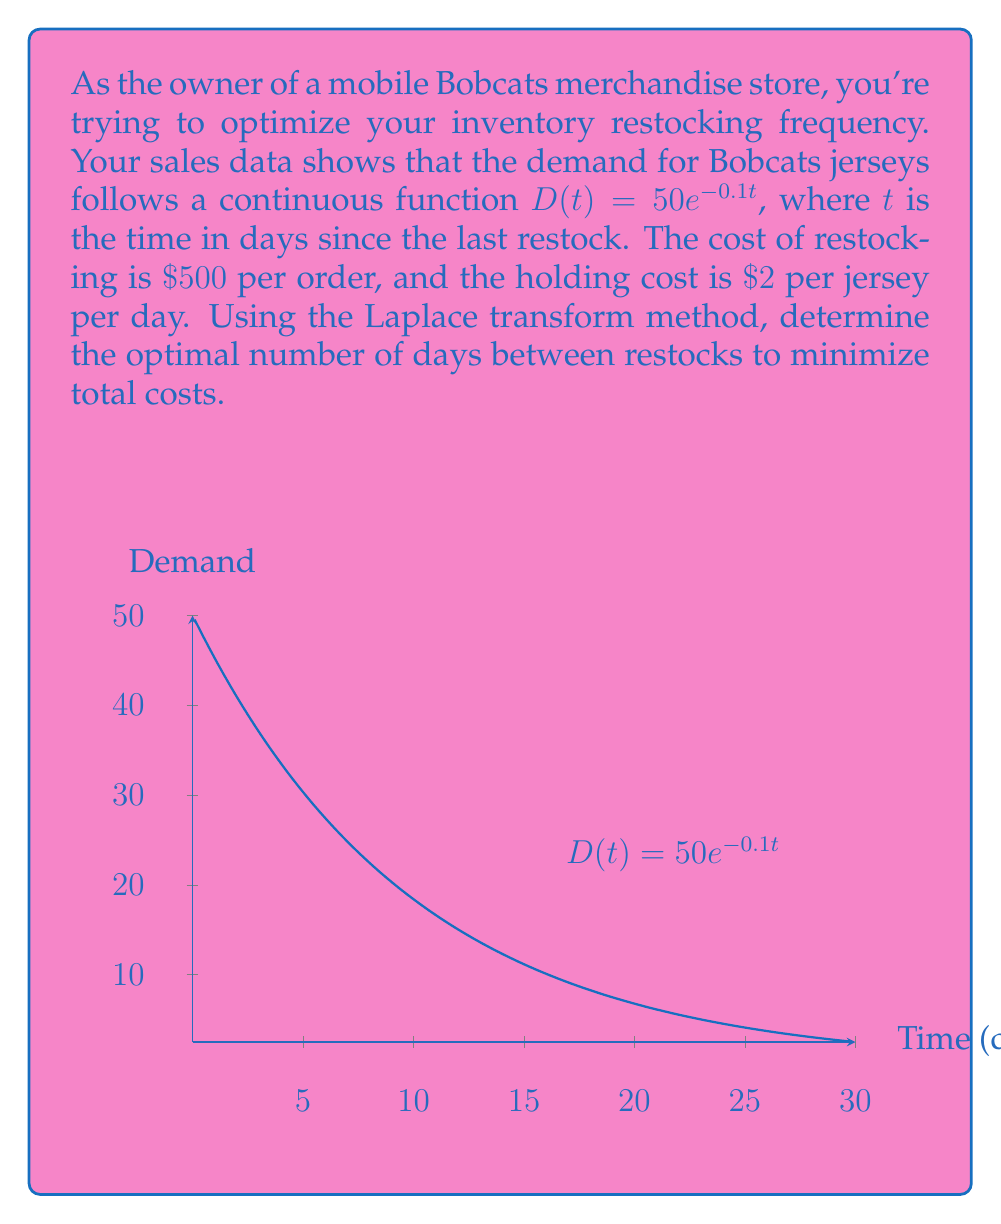Help me with this question. Let's approach this step-by-step using the Laplace transform method:

1) First, we need to find the total number of jerseys sold over a cycle of length $T$. This is the integral of the demand function:

   $Q(T) = \int_0^T 50e^{-0.1t} dt = -500e^{-0.1t}|_0^T = 500(1-e^{-0.1T})$

2) The average inventory level over the cycle is:

   $\bar{I} = \frac{1}{T}\int_0^T (Q(T) - \int_0^t 50e^{-0.1\tau} d\tau) dt$

3) Simplifying this expression:

   $\bar{I} = \frac{500}{T}(1-e^{-0.1T}) - \frac{5000}{T}(0.1T + e^{-0.1T} - 1)$

4) The total cost per cycle includes the ordering cost and the holding cost:

   $TC(T) = 500 + 2\bar{I}T$

5) The average cost per day is:

   $AC(T) = \frac{TC(T)}{T} = \frac{500}{T} + 2\bar{I}$

6) To find the optimal $T$, we need to minimize $AC(T)$. In the time domain, this would involve differentiating $AC(T)$ and setting it to zero, which is complex. Instead, we'll use the Laplace transform.

7) Taking the Laplace transform of $AC(T)$:

   $\mathcal{L}\{AC(T)\} = 500\cdot\frac{1}{s^2} + 2\mathcal{L}\{\bar{I}\}$

8) The optimal $T$ occurs when the derivative of $AC(T)$ is zero. In the Laplace domain, this is equivalent to:

   $s^2\mathcal{L}\{AC(T)\} = 500 + 2s^2\mathcal{L}\{\bar{I}\}$

9) Substituting the expression for $\bar{I}$ and simplifying:

   $500 + 1000(1-\frac{s}{s+0.1}) = 0$

10) Solving this equation:

    $s = 0.1(\sqrt{2} - 1)$

11) The optimal time $T^*$ is the inverse of this:

    $T^* = \frac{1}{0.1(\sqrt{2} - 1)} \approx 24.14$ days
Answer: $24.14$ days 